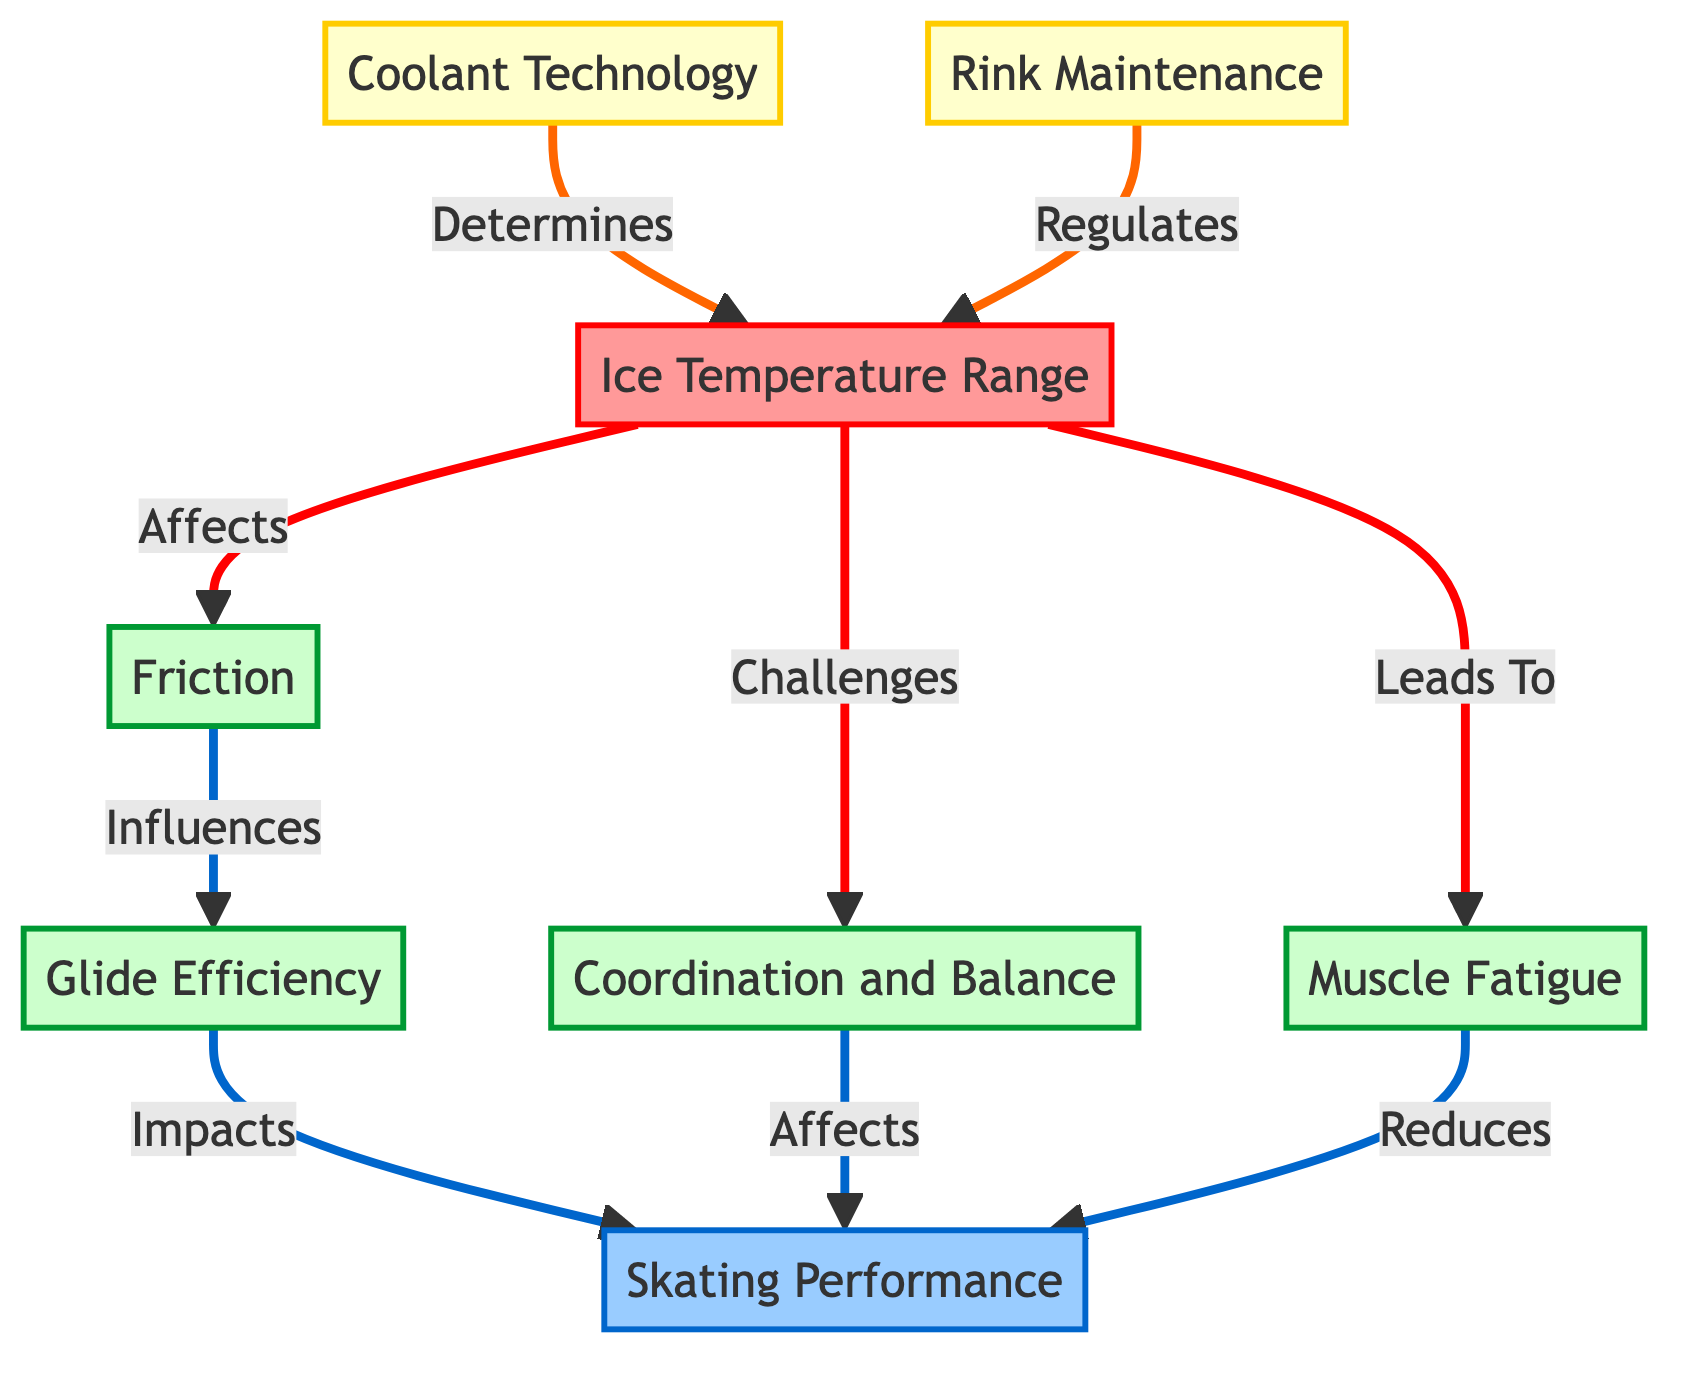What are the two technologies that influence ice temperature? The diagram shows two technologies, "Coolant Technology" and "Rink Maintenance". These are the only two connections leading to the "Ice Temperature Range".
Answer: Coolant Technology, Rink Maintenance How many factors affect skating performance? The diagram indicates three factors leading to "Skating Performance": "Friction", "Coordination and Balance", and "Muscle Fatigue". Count of these nodes provides the answer.
Answer: 3 What is the direct effect of ice temperature on glide efficiency? The diagram connects "Ice Temperature Range" to "Friction", which then influences "Glide Efficiency". This shows that ice temperature affects glide indirectly through friction.
Answer: Influences Which is the first factor impacted by ice temperature? The diagram shows that the first factor affected by "Ice Temperature Range" is "Friction", indicated by a direct arrow leading from the temperature node.
Answer: Friction What does muscle fatigue reduce? The flowchart shows that "Muscle Fatigue" leads to a reduction in "Skating Performance", clearly establishing this cause-and-effect relationship.
Answer: Skating Performance How does coordination and balance relate to skating performance? The diagram illustrates that "Coordination and Balance" has a direct link affecting "Skating Performance", indicating their relationship is a contributing factor.
Answer: Affects What outcome does glide efficiency have on skating performance? The flowchart specifies that "Glide Efficiency" impacts "Skating Performance" directly, indicating a direct relationship between these nodes.
Answer: Impacts Which element is regulated by rink maintenance? The diagram specifies that "Rink Maintenance" regulates the "Ice Temperature Range", showing its controlling relationship with temperature.
Answer: Ice Temperature Range What is the general relationship between ice temperature and muscle fatigue? The diagram indicates that "Ice Temperature Range" leads to "Muscle Fatigue", establishing a direct relationship where changes in temperature can affect fatigue levels.
Answer: Leads To 